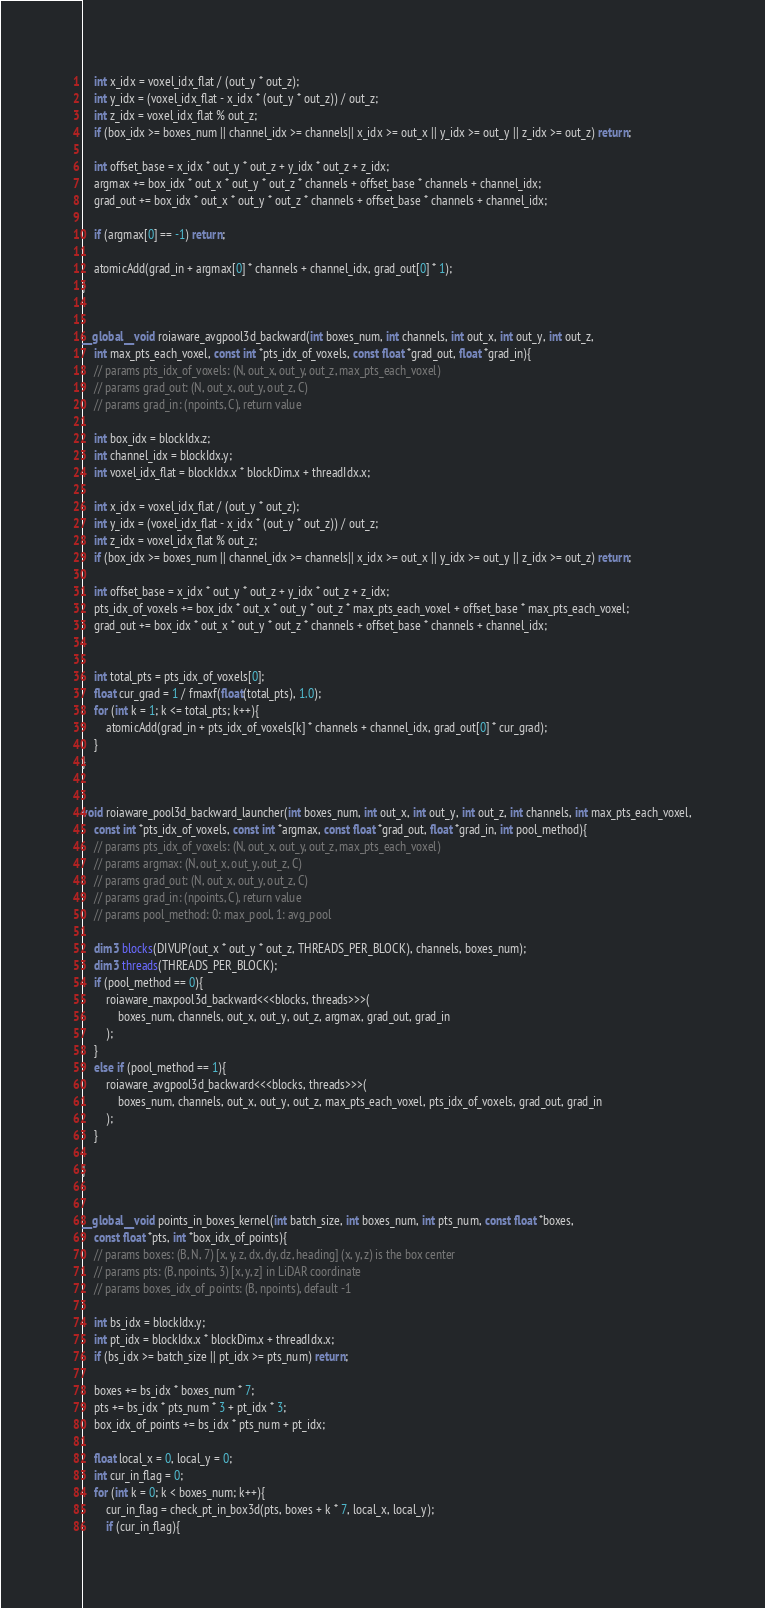<code> <loc_0><loc_0><loc_500><loc_500><_Cuda_>    int x_idx = voxel_idx_flat / (out_y * out_z);
    int y_idx = (voxel_idx_flat - x_idx * (out_y * out_z)) / out_z;
    int z_idx = voxel_idx_flat % out_z;
    if (box_idx >= boxes_num || channel_idx >= channels|| x_idx >= out_x || y_idx >= out_y || z_idx >= out_z) return;

    int offset_base = x_idx * out_y * out_z + y_idx * out_z + z_idx;
    argmax += box_idx * out_x * out_y * out_z * channels + offset_base * channels + channel_idx;
    grad_out += box_idx * out_x * out_y * out_z * channels + offset_base * channels + channel_idx;

    if (argmax[0] == -1) return;

    atomicAdd(grad_in + argmax[0] * channels + channel_idx, grad_out[0] * 1);
}


__global__ void roiaware_avgpool3d_backward(int boxes_num, int channels, int out_x, int out_y, int out_z,
    int max_pts_each_voxel, const int *pts_idx_of_voxels, const float *grad_out, float *grad_in){
    // params pts_idx_of_voxels: (N, out_x, out_y, out_z, max_pts_each_voxel)
    // params grad_out: (N, out_x, out_y, out_z, C)
    // params grad_in: (npoints, C), return value

    int box_idx = blockIdx.z;
    int channel_idx = blockIdx.y;
    int voxel_idx_flat = blockIdx.x * blockDim.x + threadIdx.x;

    int x_idx = voxel_idx_flat / (out_y * out_z);
    int y_idx = (voxel_idx_flat - x_idx * (out_y * out_z)) / out_z;
    int z_idx = voxel_idx_flat % out_z;
    if (box_idx >= boxes_num || channel_idx >= channels|| x_idx >= out_x || y_idx >= out_y || z_idx >= out_z) return;

    int offset_base = x_idx * out_y * out_z + y_idx * out_z + z_idx;
    pts_idx_of_voxels += box_idx * out_x * out_y * out_z * max_pts_each_voxel + offset_base * max_pts_each_voxel;
    grad_out += box_idx * out_x * out_y * out_z * channels + offset_base * channels + channel_idx;


    int total_pts = pts_idx_of_voxels[0];
    float cur_grad = 1 / fmaxf(float(total_pts), 1.0);
    for (int k = 1; k <= total_pts; k++){
        atomicAdd(grad_in + pts_idx_of_voxels[k] * channels + channel_idx, grad_out[0] * cur_grad);
    }
}


void roiaware_pool3d_backward_launcher(int boxes_num, int out_x, int out_y, int out_z, int channels, int max_pts_each_voxel,
    const int *pts_idx_of_voxels, const int *argmax, const float *grad_out, float *grad_in, int pool_method){
    // params pts_idx_of_voxels: (N, out_x, out_y, out_z, max_pts_each_voxel)
    // params argmax: (N, out_x, out_y, out_z, C)
    // params grad_out: (N, out_x, out_y, out_z, C)
    // params grad_in: (npoints, C), return value
    // params pool_method: 0: max_pool, 1: avg_pool

    dim3 blocks(DIVUP(out_x * out_y * out_z, THREADS_PER_BLOCK), channels, boxes_num);
    dim3 threads(THREADS_PER_BLOCK);
    if (pool_method == 0){
        roiaware_maxpool3d_backward<<<blocks, threads>>>(
            boxes_num, channels, out_x, out_y, out_z, argmax, grad_out, grad_in
        );
    }
    else if (pool_method == 1){
        roiaware_avgpool3d_backward<<<blocks, threads>>>(
            boxes_num, channels, out_x, out_y, out_z, max_pts_each_voxel, pts_idx_of_voxels, grad_out, grad_in
        );
    }

}


__global__ void points_in_boxes_kernel(int batch_size, int boxes_num, int pts_num, const float *boxes,
    const float *pts, int *box_idx_of_points){
    // params boxes: (B, N, 7) [x, y, z, dx, dy, dz, heading] (x, y, z) is the box center
    // params pts: (B, npoints, 3) [x, y, z] in LiDAR coordinate
    // params boxes_idx_of_points: (B, npoints), default -1

    int bs_idx = blockIdx.y;
    int pt_idx = blockIdx.x * blockDim.x + threadIdx.x;
    if (bs_idx >= batch_size || pt_idx >= pts_num) return;

    boxes += bs_idx * boxes_num * 7;
    pts += bs_idx * pts_num * 3 + pt_idx * 3;
    box_idx_of_points += bs_idx * pts_num + pt_idx;

    float local_x = 0, local_y = 0;
    int cur_in_flag = 0;
    for (int k = 0; k < boxes_num; k++){
        cur_in_flag = check_pt_in_box3d(pts, boxes + k * 7, local_x, local_y);
        if (cur_in_flag){</code> 